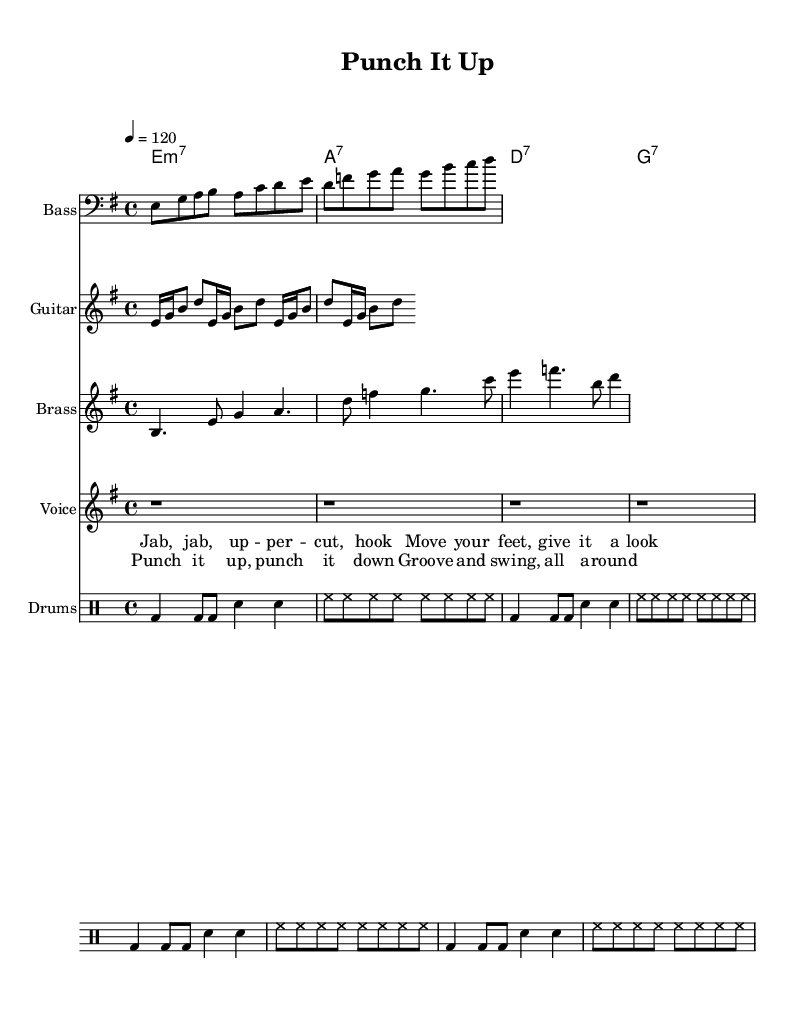What is the key signature of this music? The key signature is indicated by the sharps or flats at the beginning of the staff. In this case, there are no sharps or flats in the key signature, meaning it is in E minor.
Answer: E minor What is the time signature of this music? The time signature is found at the beginning of the score, looking for the two numbers stacked on top of each other. Here, it is 4 over 4, meaning four beats per measure.
Answer: 4/4 What is the tempo marking of this music? The tempo marking tells you how fast the music should be played. It is indicated by the number followed by a symbol, in this case, it states 4 equals 120, which indicates the beats per minute.
Answer: 120 How many measures are in the bass line? To find the number of measures, count each group of notes that are separated by vertical lines (bar lines). The bass line contains eight measures in total.
Answer: Eight What is the primary rhythmic feel of the drum staff? The drum staff's rhythmic feel can be identified by the patterns of the notes written on it. It consists predominantly of bass drum and snare drum notes, suggesting a typical funky beat that emphasizes groove.
Answer: Funky groove What chord is played in the first measure? The first measure in the chord names section indicates the specific chord being played, which is noted as E minor 7, represented by the notation shown there.
Answer: E minor 7 How many lines are in the brass section? By examining the notation in the brass section, each group of notes and rests indicates a line, revealing that the brass section has four lines of notes.
Answer: Four 